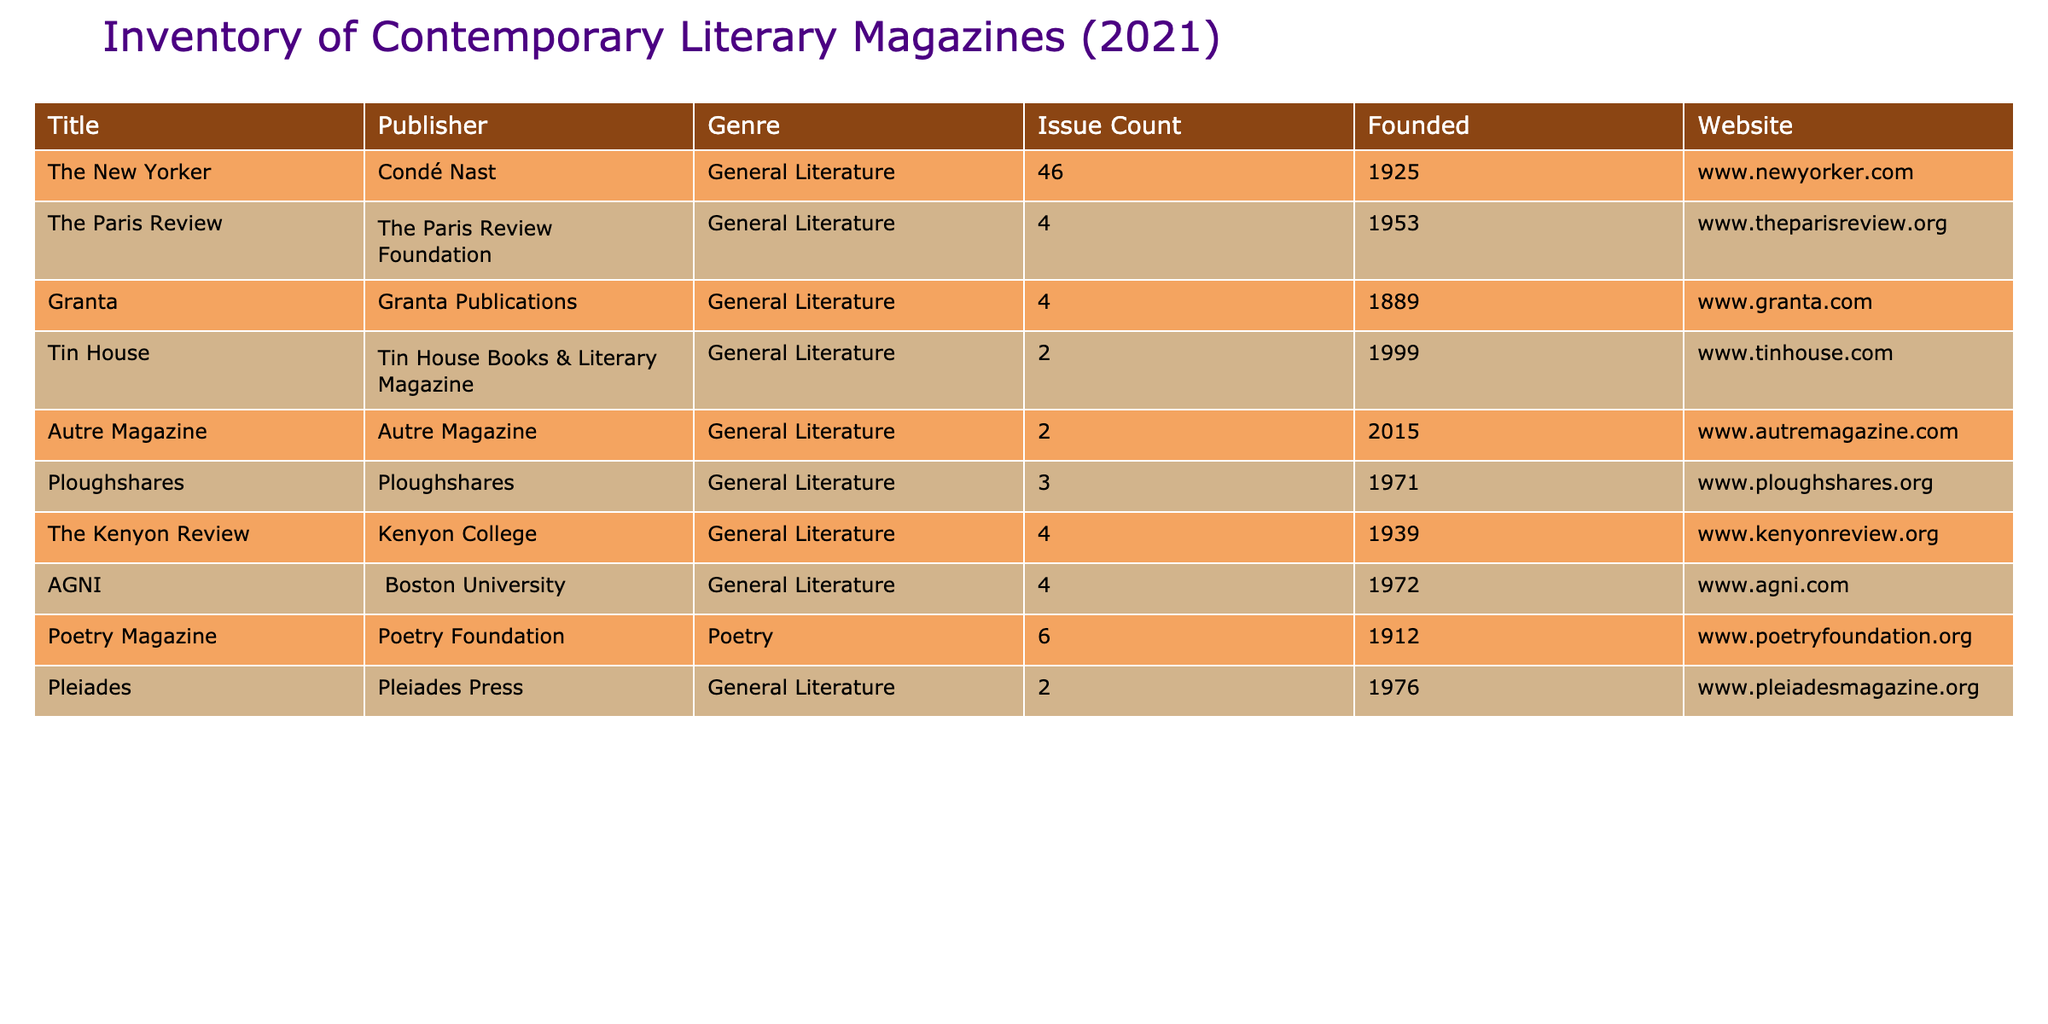What is the title of the oldest literary magazine listed? The table shows that "Granta" was founded in 1889, which is earlier than all other magazines listed.
Answer: Granta How many issues did Poetry Magazine publish in 2021? According to the table, Poetry Magazine has an issue count of 6 for the year 2021.
Answer: 6 Which magazine has the highest issue count? By comparing the issue counts in the table, The New Yorker has 46 issues, which is the highest among the listed magazines.
Answer: The New Yorker Is "The Paris Review" a poetry magazine? The genre for "The Paris Review" is listed as General Literature, not Poetry, indicating that it is not classified as a poetry magazine.
Answer: No What is the average issue count of the magazines founded after 2000? The magazines founded after 2000 in the table are "Tin House" (2), "Autre Magazine" (2), and "Pleiades" (2). The average is (2 + 2 + 2) / 3 = 2.
Answer: 2 How many magazines were founded before 1950? By checking the founded years in the table, there are 6 magazines: "Granta" (1889), "Poetry Magazine" (1912), "The New Yorker" (1925), "The Kenyon Review" (1939), "AGNI" (1972), and "The Paris Review" (1953). Among these, only Granta, Poetry Magazine, The New Yorker, and The Kenyon Review were founded before 1950, which sums up to 4 magazines.
Answer: 4 Which publisher is associated with "The Kenyon Review"? The table indicates that "The Kenyon Review" is published by Kenyon College.
Answer: Kenyon College What is the total number of issues published by all magazines? Summing up the issue counts: 46 (The New Yorker) + 4 (The Paris Review) + 4 (Granta) + 2 (Tin House) + 2 (Autre Magazine) + 3 (Ploughshares) + 4 (The Kenyon Review) + 4 (AGNI) + 6 (Poetry Magazine) + 2 (Pleiades) totals to 77.
Answer: 77 